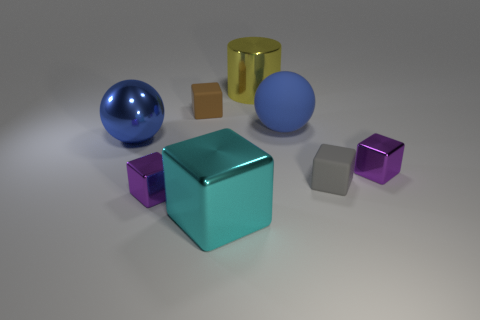Subtract 3 blocks. How many blocks are left? 2 Subtract all cyan blocks. How many blocks are left? 4 Subtract all cyan shiny cubes. How many cubes are left? 4 Add 1 tiny brown blocks. How many objects exist? 9 Subtract all cyan blocks. Subtract all gray balls. How many blocks are left? 4 Subtract all balls. How many objects are left? 6 Subtract all small yellow metal cubes. Subtract all tiny brown cubes. How many objects are left? 7 Add 3 blue rubber balls. How many blue rubber balls are left? 4 Add 5 shiny spheres. How many shiny spheres exist? 6 Subtract 1 blue spheres. How many objects are left? 7 